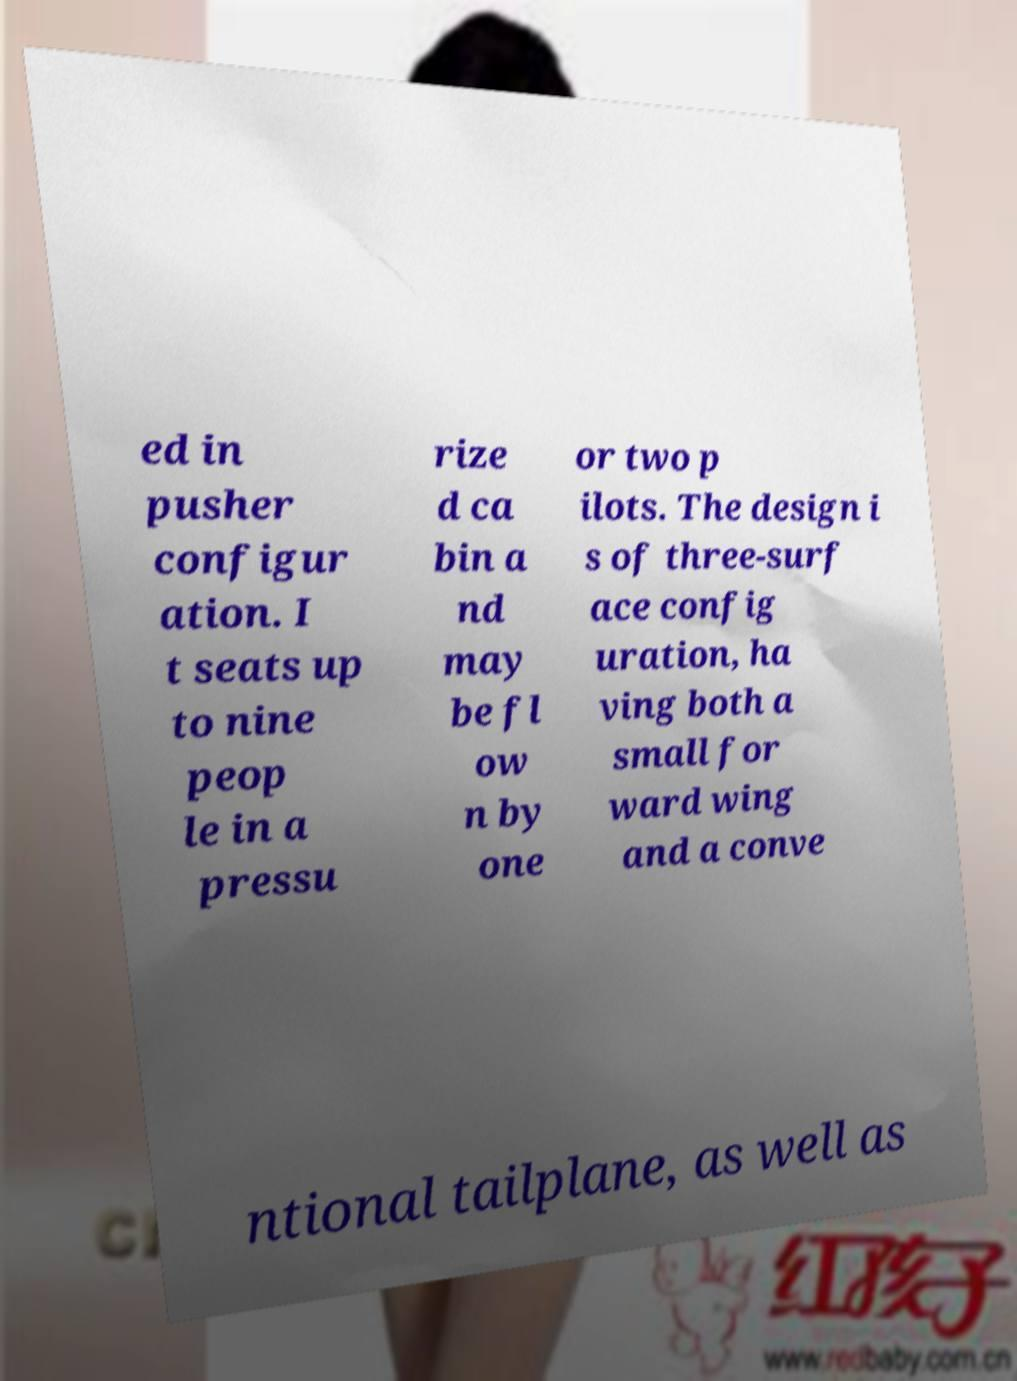There's text embedded in this image that I need extracted. Can you transcribe it verbatim? ed in pusher configur ation. I t seats up to nine peop le in a pressu rize d ca bin a nd may be fl ow n by one or two p ilots. The design i s of three-surf ace config uration, ha ving both a small for ward wing and a conve ntional tailplane, as well as 